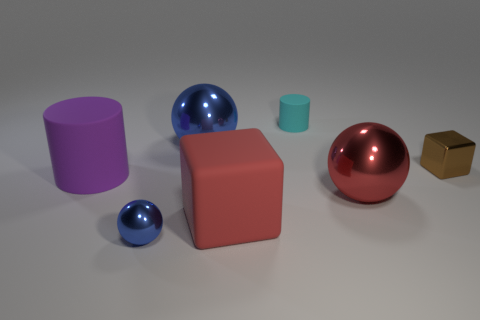Is the number of tiny spheres to the left of the tiny metallic ball less than the number of big purple rubber cylinders that are in front of the large block?
Give a very brief answer. No. What is the shape of the blue thing behind the shiny thing that is in front of the red thing that is on the left side of the tiny cyan matte object?
Your answer should be very brief. Sphere. The metallic object that is both behind the small shiny ball and in front of the small brown metallic object has what shape?
Give a very brief answer. Sphere. Are there any small blocks that have the same material as the big blue thing?
Make the answer very short. Yes. What is the size of the shiny object that is the same color as the small ball?
Offer a terse response. Large. There is a cylinder that is to the left of the cyan matte object; what color is it?
Make the answer very short. Purple. There is a big purple object; does it have the same shape as the small thing in front of the brown metallic cube?
Provide a succinct answer. No. Is there a large sphere of the same color as the tiny metallic sphere?
Give a very brief answer. Yes. The block that is made of the same material as the cyan cylinder is what size?
Offer a terse response. Large. There is a small metal thing that is in front of the purple object; does it have the same shape as the purple matte thing?
Keep it short and to the point. No. 